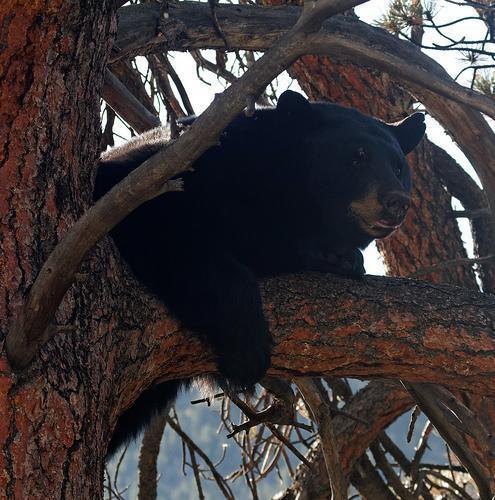How many bears are eating food on the tree?
Give a very brief answer. 0. 